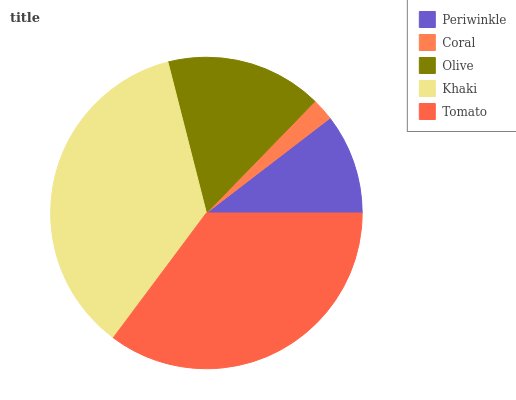Is Coral the minimum?
Answer yes or no. Yes. Is Khaki the maximum?
Answer yes or no. Yes. Is Olive the minimum?
Answer yes or no. No. Is Olive the maximum?
Answer yes or no. No. Is Olive greater than Coral?
Answer yes or no. Yes. Is Coral less than Olive?
Answer yes or no. Yes. Is Coral greater than Olive?
Answer yes or no. No. Is Olive less than Coral?
Answer yes or no. No. Is Olive the high median?
Answer yes or no. Yes. Is Olive the low median?
Answer yes or no. Yes. Is Tomato the high median?
Answer yes or no. No. Is Khaki the low median?
Answer yes or no. No. 